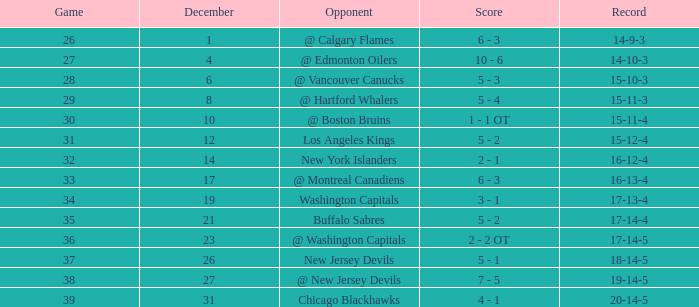Game larger than 34, and a December smaller than 23 had what record? 17-14-4. 